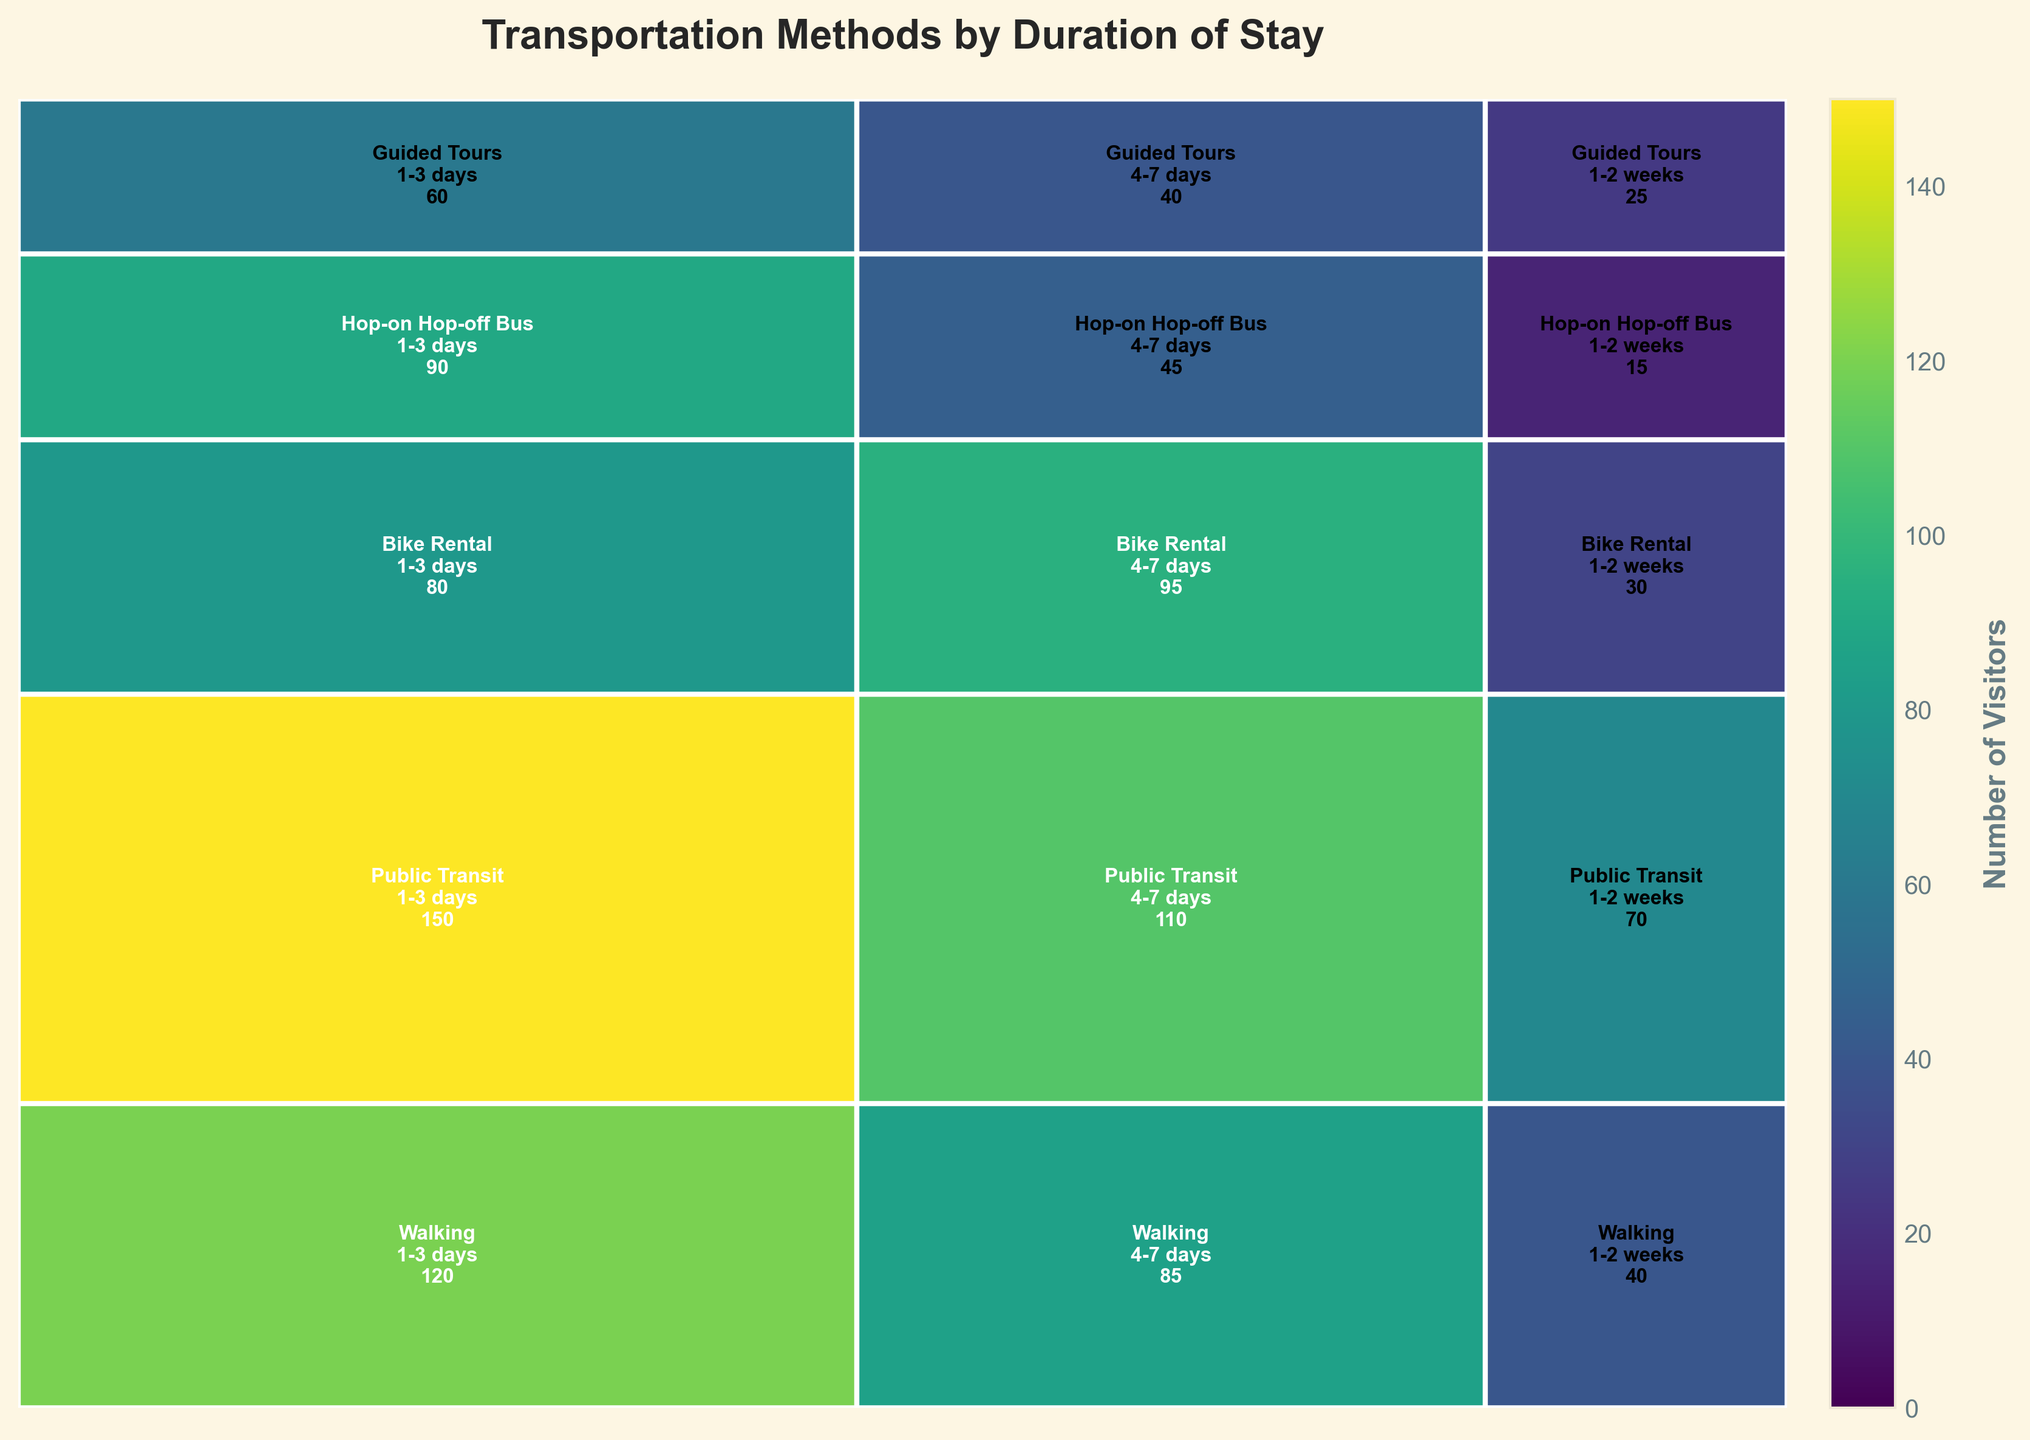What's the title of the plot? The title of the plot is usually given at the top and is the main heading that describes what the plot is about. In this case, the title "Transportation Methods by Duration of Stay" is centered at the top of the plot.
Answer: Transportation Methods by Duration of Stay Which transportation method has the highest number of visitors for the 1-3 days duration? To find this, look for the largest rectangle in the 1-3 days section of the plot. The height represents the count for each transportation method. The largest rectangle under 1-3 days is for Public Transit.
Answer: Public Transit What is the total number of visitors for Bike Rental? Sum up the counts for Bike Rental under each duration: 80 (1-3 days) + 95 (4-7 days) + 30 (1-2 weeks) = 205.
Answer: 205 Which duration has the least number of visitors for Guided Tours, and how many? Look at the Guided Tours section and compare the sizes of the rectangles for each duration. The smallest rectangle is for the 1-2 weeks duration with a count of 25.
Answer: 1-2 weeks, 25 Compare the number of visitors for Walking and Public Transit over the 4-7 days duration. Which one is higher and by how much? Check the counts for Walking and Public Transit for the 4-7 days duration. Walking has 85 visitors and Public Transit has 110 visitors. The difference is 110 - 85 = 25.
Answer: Public Transit is higher by 25 Which transportation method sees a sharp decline as the duration of stay increases, and by how much between 1-3 days and 1-2 weeks? Identify the method with the most significant drop-off. Look at Hop-on Hop-off Bus: 90 (1-3 days) to 15 (1-2 weeks). The decline is 90 - 15 = 75.
Answer: Hop-on Hop-off Bus, 75 What is the most popular transportation method for the 4-7 days duration? Check the largest rectangle in the 4-7 days section. It's for Public Transit with 110 visitors.
Answer: Public Transit If a visitor is staying for 1-2 weeks, which transportation method are they least likely to use? Look for the smallest rectangle in the 1-2 weeks segment across all methods. The smallest rectangle is for the Hop-on Hop-off Bus with 15 visitors.
Answer: Hop-on Hop-off Bus Is there any transportation method that has more than 100 visitors for any duration? If so, which one and for what duration? Look at the counts and find any transportation method exceeding 100 visitors. Public Transit has more than 100 visitors (150) for the 1-3 days duration.
Answer: Public Transit, 1-3 days 